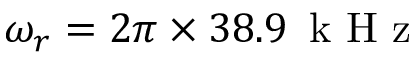Convert formula to latex. <formula><loc_0><loc_0><loc_500><loc_500>\omega _ { r } = 2 \pi \times 3 8 . 9 \, k H z</formula> 